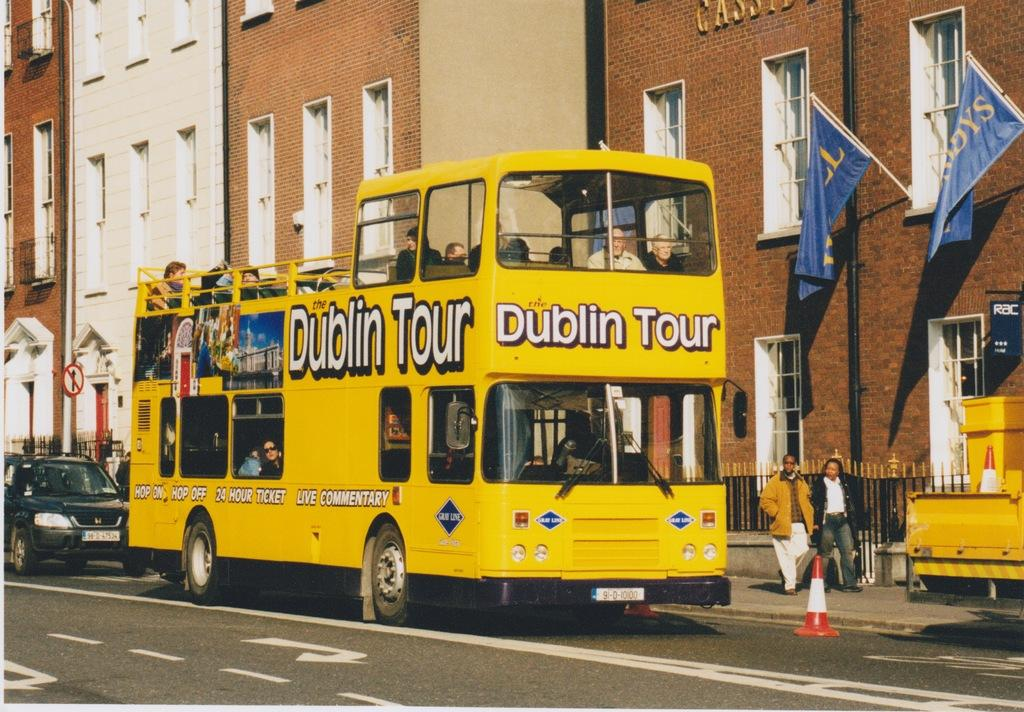<image>
Present a compact description of the photo's key features. A yellow two decker Dublin tour bus drives down the road. 